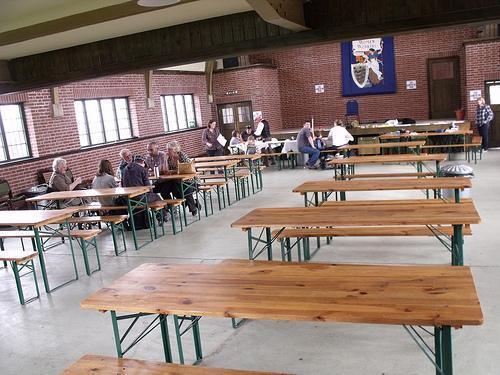How many people are visible in the photo?
Give a very brief answer. 14. How many doors are visible in the scene?
Give a very brief answer. 3. How many windows are visible in the photo?
Give a very brief answer. 3. 